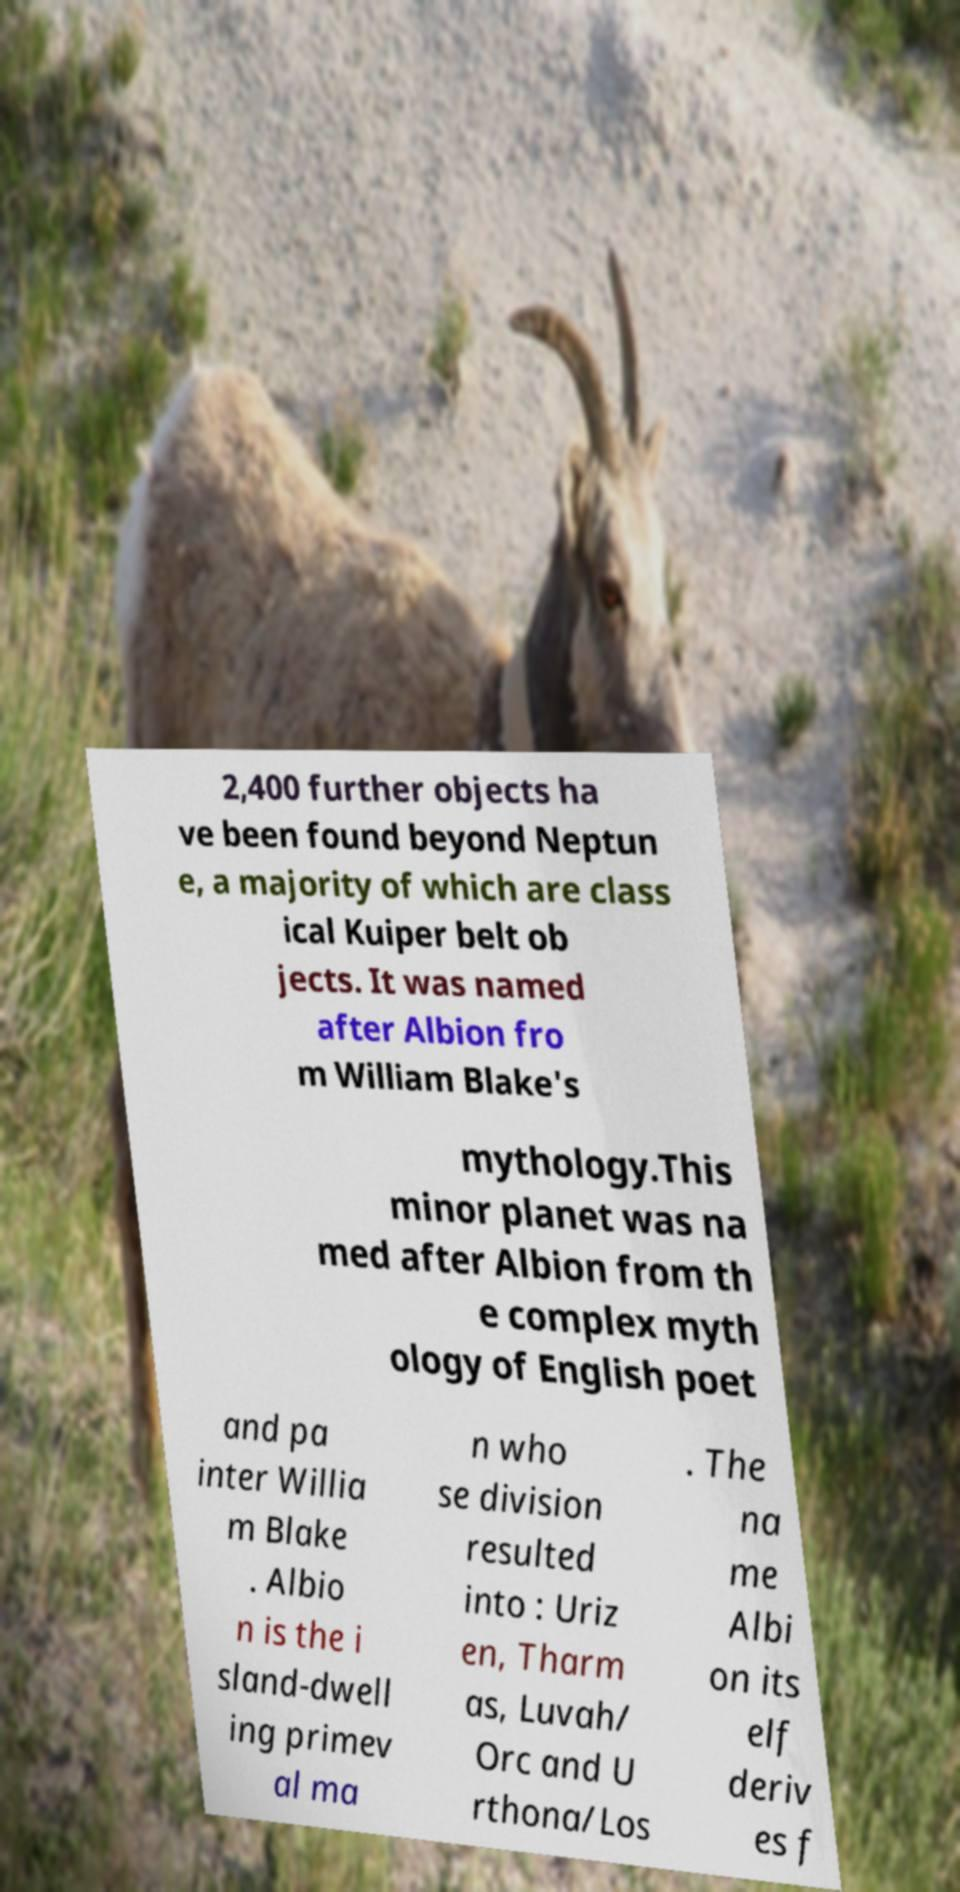Can you accurately transcribe the text from the provided image for me? 2,400 further objects ha ve been found beyond Neptun e, a majority of which are class ical Kuiper belt ob jects. It was named after Albion fro m William Blake's mythology.This minor planet was na med after Albion from th e complex myth ology of English poet and pa inter Willia m Blake . Albio n is the i sland-dwell ing primev al ma n who se division resulted into : Uriz en, Tharm as, Luvah/ Orc and U rthona/Los . The na me Albi on its elf deriv es f 